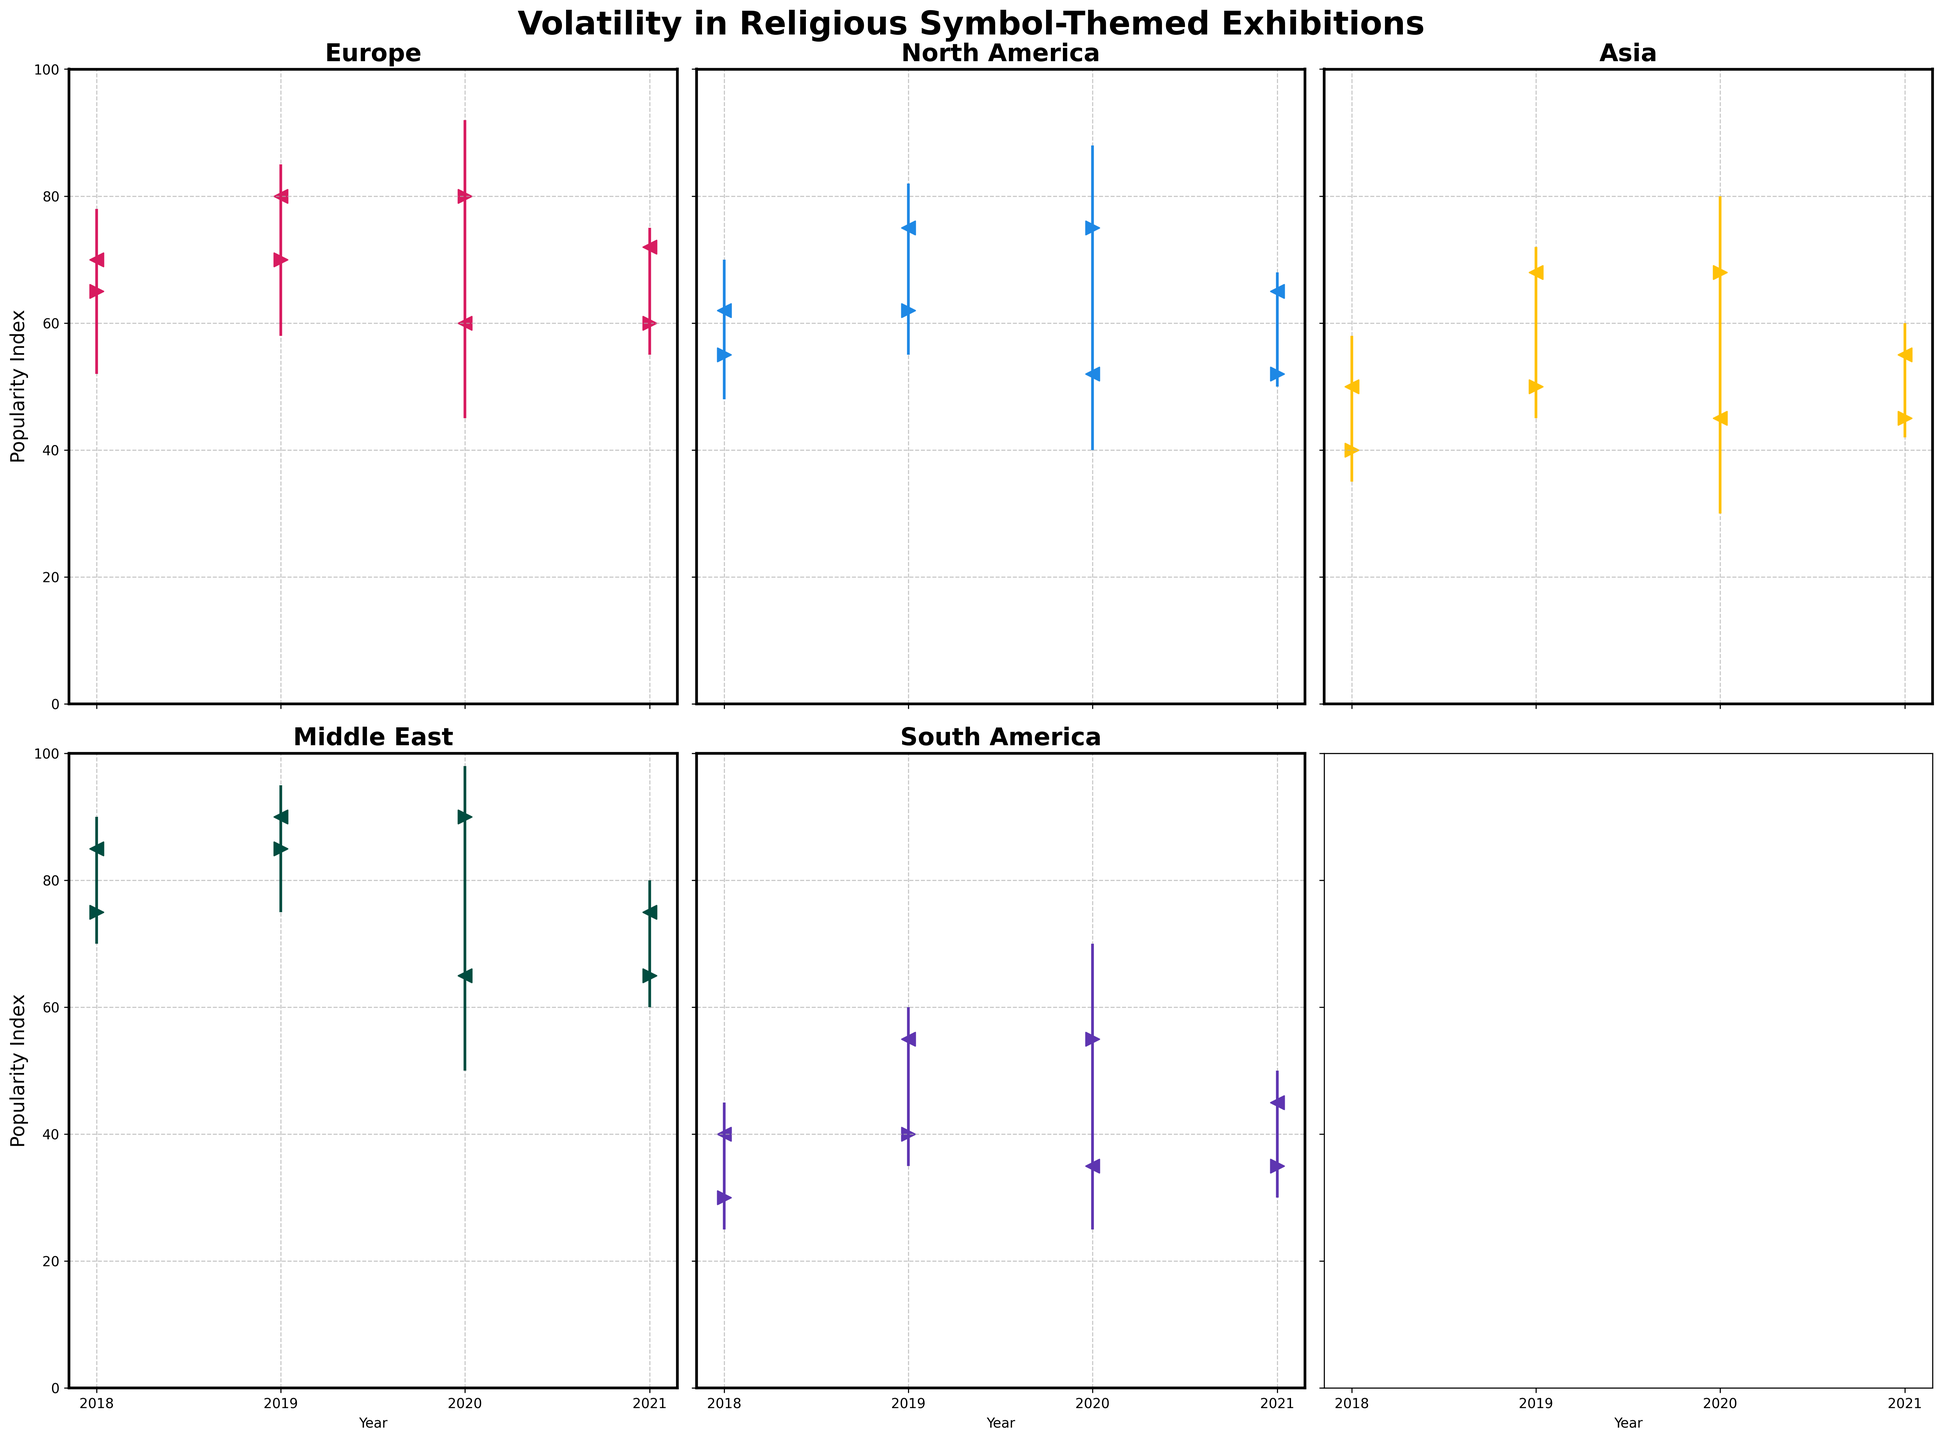Which region shows the highest peak in popularity? By examining the highest point on the vertical lines, we can see that the Middle East in 2019 reached the highest peak with a popularity index of 95.
Answer: Middle East in 2019 What is the overall trend for Europe from 2018 to 2021? Looking at the 'Open' and 'Close' markers, Europe starts at 65 in 2018, peaks at 80 in 2019, drops to 60 in 2020, and rises slightly to 72 in 2021. This indicates volatility with no clear upward or downward trend over the years.
Answer: Volatile trend Which region experienced the biggest drop in popularity between two consecutive years? The biggest drop can be observed by comparing the 'Open' and 'Close' values of consecutive years. For North America from 2019 to 2020, the popularity index fell from 75 to 52, resulting in a 23 points drop.
Answer: North America (2019 to 2020) How did the popularity of exhibitions in South America change from 2019 to 2021? South America's popularity index 'Closed' at 55 in 2019 and dropped to 35 in 2020, then slightly increased to 45 in 2021, indicating an initial decline followed by a partial recovery.
Answer: Decline then partial recovery What is the average 'Close' value for Asia from 2018 to 2021? To find the average, sum the 'Close' values for Asia over these years: (50 + 68 + 45 + 55) = 218, and divide by 4. So, the average is 218 / 4 = 54.5.
Answer: 54.5 Did the Middle East experience any significant volatility in 2020? Volatility can be assessed by the length of the vertical lines. The Middle East in 2020 has a considerable range from 50 to 98, indicating significant volatility.
Answer: Yes Which region shows a steady increase in the popularity index over the given years? By comparing 'Open' and 'Close' values across all years, none of the regions show a perfectly steady increase. However, the Middle East shows a relatively increasing trend from 2018 (85) to 2021 (75), despite a drop in 2020 (65).
Answer: Middle East (relatively increasing) What is the difference between the highest and lowest 'Close' values in North America from 2018 to 2021? North America's highest 'Close' value over these years is 75 (2019) and the lowest is 52 (2020). The difference is 75 - 52 = 23.
Answer: 23 Which year had the highest 'High' value across all regions? By examining the highest values across all years and regions, 2020 in the Middle East had the highest 'High' value of 98.
Answer: 2020 How does the volatility of Europe in 2020 compare to that of Asia in the same year? The volatility for Europe in 2020 ranges from 45 to 92 (range of 47), while Asia's ranges from 30 to 80 (range of 50). Both regions show high volatility, with Asia being slightly more volatile.
Answer: Asia is slightly more volatile 